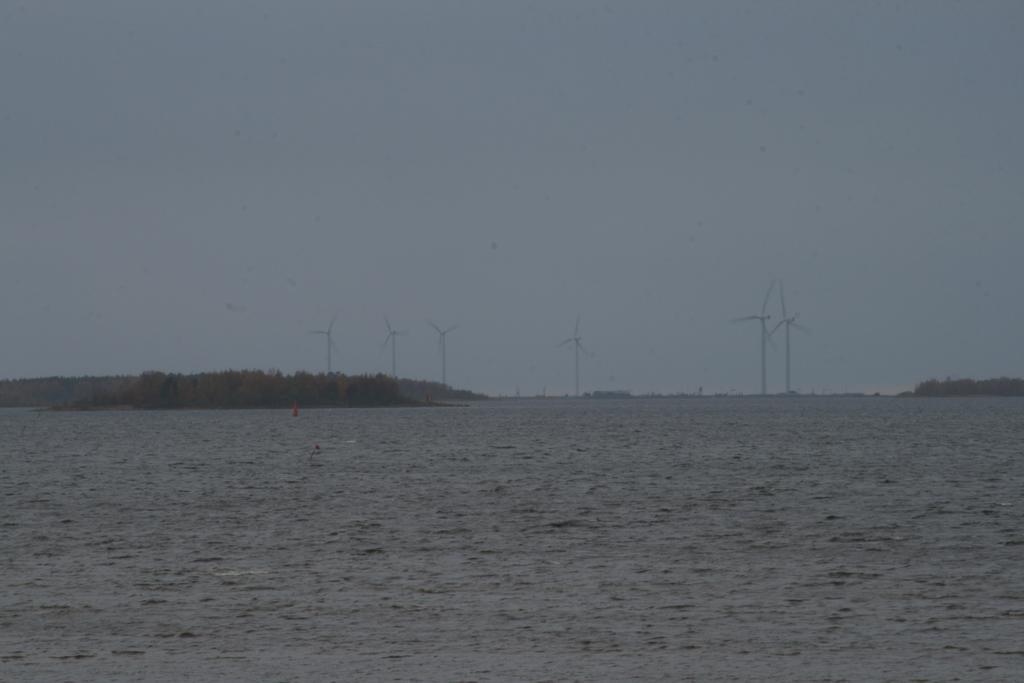Describe this image in one or two sentences. In this image we can see water, windmills, and trees. In the background there is sky. 